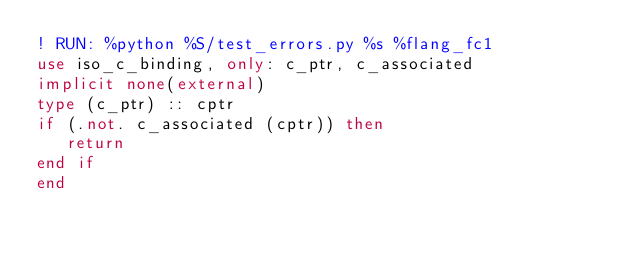<code> <loc_0><loc_0><loc_500><loc_500><_FORTRAN_>! RUN: %python %S/test_errors.py %s %flang_fc1
use iso_c_binding, only: c_ptr, c_associated
implicit none(external)
type (c_ptr) :: cptr
if (.not. c_associated (cptr)) then
   return
end if
end
</code> 